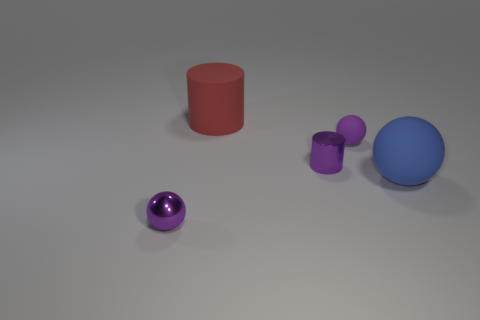Add 1 large blue shiny balls. How many objects exist? 6 Subtract all cylinders. How many objects are left? 3 Add 4 large cylinders. How many large cylinders exist? 5 Subtract 0 red cubes. How many objects are left? 5 Subtract all large cyan spheres. Subtract all large rubber objects. How many objects are left? 3 Add 3 large blue matte balls. How many large blue matte balls are left? 4 